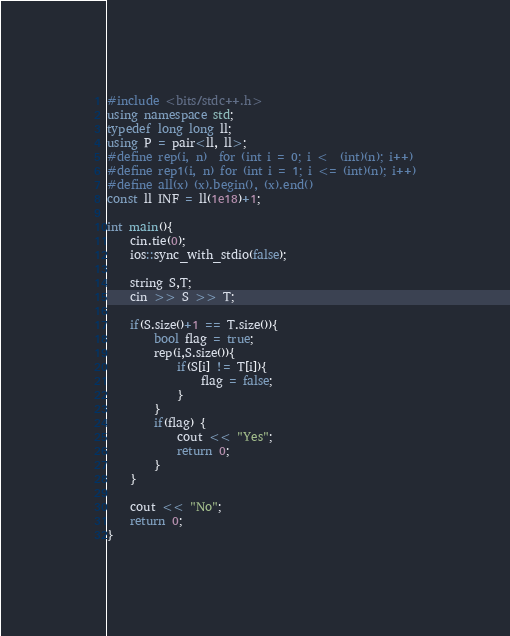<code> <loc_0><loc_0><loc_500><loc_500><_C++_>#include <bits/stdc++.h>
using namespace std;
typedef long long ll;
using P = pair<ll, ll>;
#define rep(i, n)  for (int i = 0; i <  (int)(n); i++)
#define rep1(i, n) for (int i = 1; i <= (int)(n); i++)
#define all(x) (x).begin(), (x).end()
const ll INF = ll(1e18)+1;

int main(){
    cin.tie(0);
    ios::sync_with_stdio(false);

    string S,T;
    cin >> S >> T;
    
    if(S.size()+1 == T.size()){
        bool flag = true;
        rep(i,S.size()){
            if(S[i] != T[i]){
                flag = false;
            }
        }
        if(flag) {
            cout << "Yes";
            return 0;
        }
    }

    cout << "No";
    return 0;
}</code> 